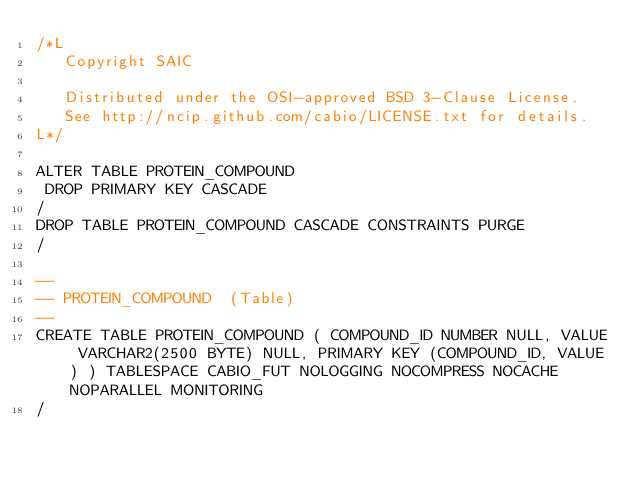<code> <loc_0><loc_0><loc_500><loc_500><_SQL_>/*L
   Copyright SAIC

   Distributed under the OSI-approved BSD 3-Clause License.
   See http://ncip.github.com/cabio/LICENSE.txt for details.
L*/

ALTER TABLE PROTEIN_COMPOUND
 DROP PRIMARY KEY CASCADE
/
DROP TABLE PROTEIN_COMPOUND CASCADE CONSTRAINTS PURGE
/

--
-- PROTEIN_COMPOUND  (Table) 
--
CREATE TABLE PROTEIN_COMPOUND ( COMPOUND_ID NUMBER NULL, VALUE VARCHAR2(2500 BYTE) NULL, PRIMARY KEY (COMPOUND_ID, VALUE) ) TABLESPACE CABIO_FUT NOLOGGING NOCOMPRESS NOCACHE NOPARALLEL MONITORING
/


</code> 